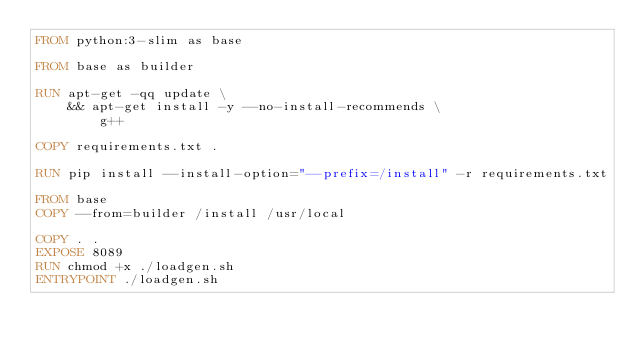Convert code to text. <code><loc_0><loc_0><loc_500><loc_500><_Dockerfile_>FROM python:3-slim as base

FROM base as builder

RUN apt-get -qq update \
    && apt-get install -y --no-install-recommends \
        g++

COPY requirements.txt .

RUN pip install --install-option="--prefix=/install" -r requirements.txt

FROM base
COPY --from=builder /install /usr/local

COPY . .
EXPOSE 8089
RUN chmod +x ./loadgen.sh
ENTRYPOINT ./loadgen.sh
</code> 